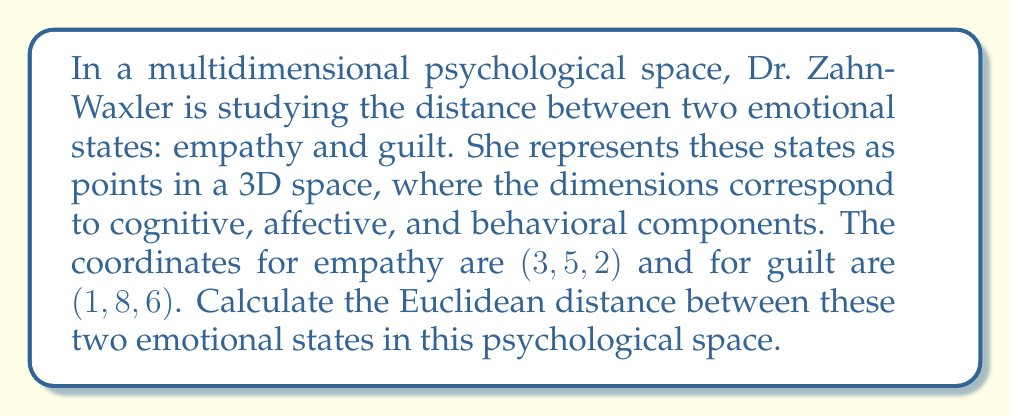What is the answer to this math problem? To solve this problem, we need to use the Euclidean distance formula in three-dimensional space. The formula is:

$$d = \sqrt{(x_2 - x_1)^2 + (y_2 - y_1)^2 + (z_2 - z_1)^2}$$

Where $(x_1, y_1, z_1)$ are the coordinates of the first point (empathy) and $(x_2, y_2, z_2)$ are the coordinates of the second point (guilt).

Let's substitute the given values:
Empathy: $(x_1, y_1, z_1) = (3, 5, 2)$
Guilt: $(x_2, y_2, z_2) = (1, 8, 6)$

Now, let's calculate each term inside the square root:

1. $(x_2 - x_1)^2 = (1 - 3)^2 = (-2)^2 = 4$
2. $(y_2 - y_1)^2 = (8 - 5)^2 = 3^2 = 9$
3. $(z_2 - z_1)^2 = (6 - 2)^2 = 4^2 = 16$

Sum these terms:

$$4 + 9 + 16 = 29$$

Now, take the square root:

$$d = \sqrt{29}$$

This is our final answer, as we cannot simplify the square root of 29 further.
Answer: $\sqrt{29}$ units 